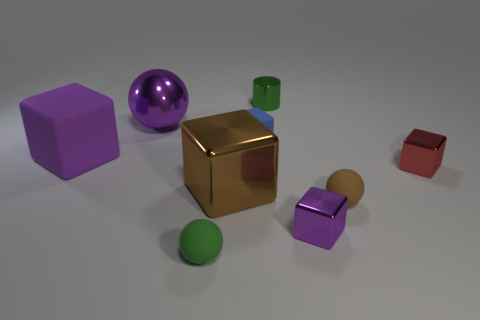Is there anything else that is the same shape as the small green metal object?
Ensure brevity in your answer.  No. How many other matte cubes have the same color as the big rubber cube?
Give a very brief answer. 0. What number of small spheres have the same material as the blue cube?
Make the answer very short. 2. What number of things are small blue cubes or purple cubes that are right of the metal sphere?
Keep it short and to the point. 2. The block on the left side of the metallic object that is on the left side of the green matte ball to the left of the brown sphere is what color?
Your response must be concise. Purple. How big is the green thing that is in front of the large purple ball?
Provide a short and direct response. Small. How many tiny objects are either brown spheres or cyan metallic things?
Give a very brief answer. 1. The tiny thing that is both in front of the shiny cylinder and behind the red metal thing is what color?
Keep it short and to the point. Blue. Are there any small purple things of the same shape as the small blue object?
Provide a succinct answer. Yes. What is the material of the green cylinder?
Make the answer very short. Metal. 